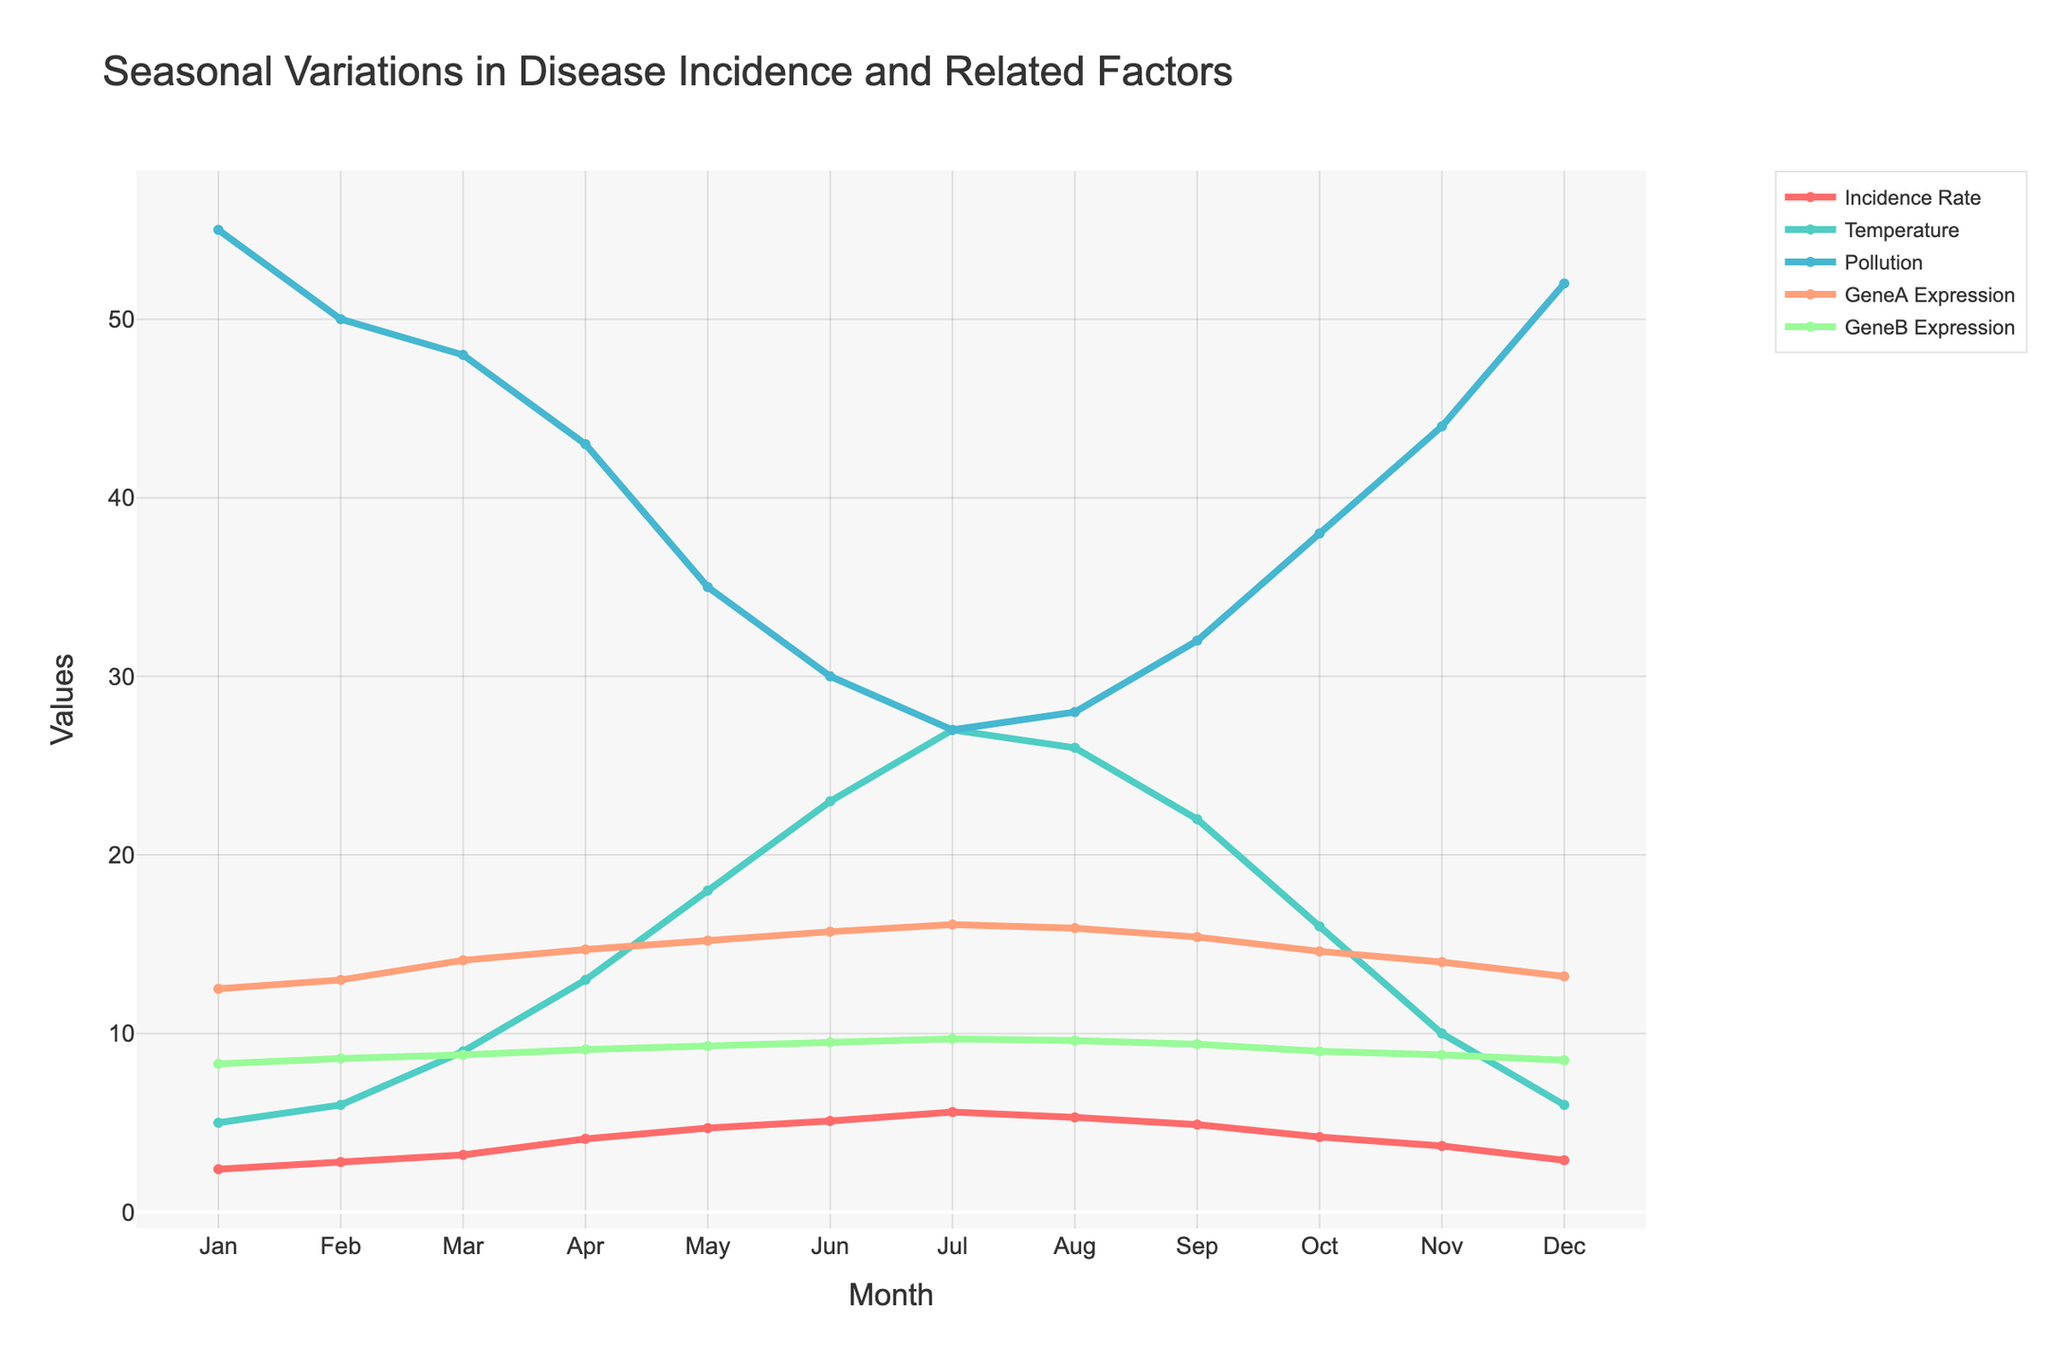What's the title of the plot? The title of the plot is located at the top and is clearly mentioned.
Answer: Seasonal Variations in Disease Incidence and Related Factors How does the incidence rate change from January to December? Trace the "Incidence Rate" line from January to December and observe the changes in values over time. Starting at 2.4 in January, it increases to a peak in July at 5.6, and then decreases to 2.9 in December.
Answer: It starts at 2.4, peaks at 5.6 in July, and ends at 2.9 Which month has the highest average temperature? Look at the "Temperature" line and identify the highest point. It peaks in July.
Answer: July What is the relationship between temperature and incidence rate in summer months? Observe the correlation between the "Temperature" line and "Incidence Rate" line for June, July, and August. Both increase in June and July, with incidence rate peaking in July, and slightly decreasing in August while temperature remains high.
Answer: Both increase to a peak in July During which months do GeneA and GeneB have the highest expression levels? Check the line representing GeneA and GeneB expression levels and identify the months with their highest values. GeneA expression peaks in July, while GeneB expression is highest in July.
Answer: Both in July What happens to pollution levels as temperature increases? Compare the "Temperature" line and "Pollution" line. As the temperature increases from January to July, pollution levels decrease from 55 to 27.
Answer: Pollution decreases as temperature increases What is the difference in incidence rate between the highest and lowest months? Identify the highest and lowest points on the "Incidence Rate" line. The highest is in July at 5.6, and the lowest is in January at 2.4. The difference is 5.6 - 2.4.
Answer: 3.2 How do pollution levels change from May to September? Look at the "Pollution" line from May (35) to September (32) and observe the changes. Pollution decreases from May to July (27) and slightly increases till September.
Answer: Decreases initially, then slightly increases Do any months show a significant drop in both incidence rate and average temperature? Compare the "Incidence Rate" and "Temperature" lines and look for simultaneous drops. From October to December, both drop significantly.
Answer: October to December In which month is the gap between GeneA and GeneB expression levels the largest? Analyze the differences between the GeneA and GeneB lines for each month. The largest gap is in July where GeneA is 16.1 and GeneB is 9.7.
Answer: July 